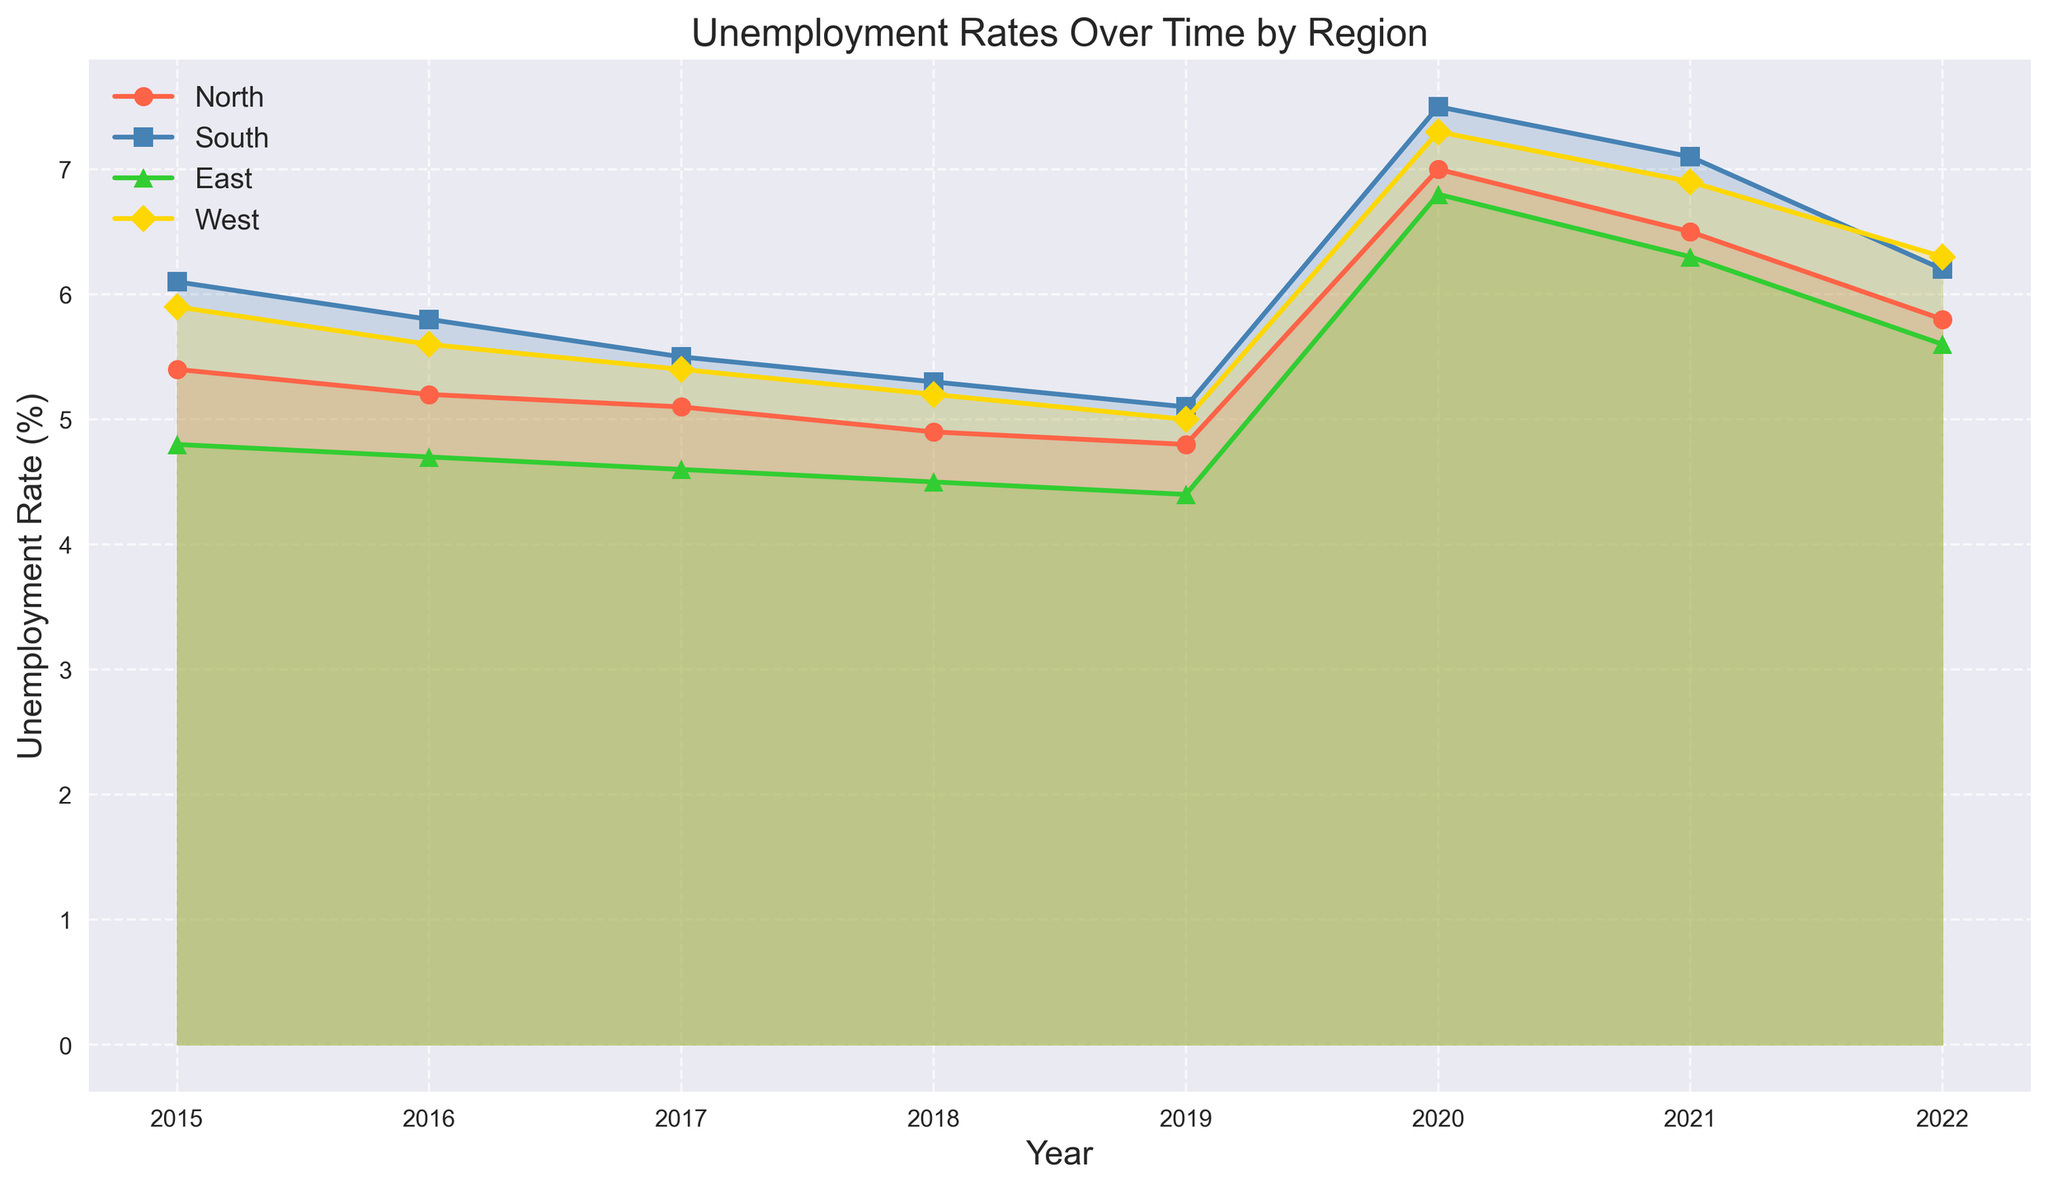What year had the highest unemployment rate in the South? To determine the year with the highest unemployment rate in the South, look at the line representing the South and find the peak point. The peak occurs in 2020.
Answer: 2020 Compare the unemployment rate in the North and East in 2020. Which region had a higher rate and by how much? Find the points on the lines for the North and East in 2020. The North has a rate of 7.0% and the East has a rate of 6.8%. Calculate the difference: 7.0 - 6.8 = 0.2%. The North has a higher rate by 0.2%.
Answer: North, 0.2% Between 2015 and 2022, in which year did the East have its lowest unemployment rate? Look for the lowest point on the line representing the East from 2015 to 2022. The lowest point is in 2019 with a rate of 4.4%.
Answer: 2019 Which region had the most significant increase in unemployment rate from 2019 to 2020, and what was the increase? Check the difference in unemployment rates for each region between 2019 and 2020. North: 7.0 - 4.8 = 2.2; South: 7.5 - 5.1 = 2.4; East: 6.8 - 4.4 = 2.4; West: 7.3 - 5.0 = 2.3. South and East had the most significant increase of 2.4%.
Answer: South and East, 2.4% What is the average unemployment rate in the West from 2015 to 2022? Add the unemployment rates in the West from 2015 to 2022 and divide by the number of years. (5.9 + 5.6 + 5.4 + 5.2 + 5.0 + 7.3 + 6.9 + 6.3) / 8 = 6.075%.
Answer: 6.075% Which region had the lowest unemployment rate in 2018, and what was the rate? Find the lowest point among all regions in 2018. The East region had the lowest rate of 4.5%.
Answer: East, 4.5% Determine the trend of unemployment rates in the North from 2015 to 2022. Is it increasing, decreasing, or fluctuating? Examine the line representing the North from 2015 to 2022. From 2015 to 2019, it generally decreases, spikes in 2020, then decreases again through 2022. Overall, it shows a decreasing trend with a significant fluctuation in 2020 due to the spike.
Answer: Decreasing with fluctuation What is the difference between the highest and lowest unemployment rates in the West from 2015 to 2022? Identify the highest and lowest points on the line representing the West between 2015 and 2022. The highest rate is 7.3% in 2020 and the lowest rate is 5.0% in 2019. The difference is 7.3 - 5.0 = 2.3%.
Answer: 2.3% In which year did all regions experience a rise in unemployment rates, and what is the likely reason? Look for the year where all lines rise. This occurs in 2020. The likely reason is the global impact of the COVID-19 pandemic, which caused widespread job losses.
Answer: 2020, COVID-19 pandemic 